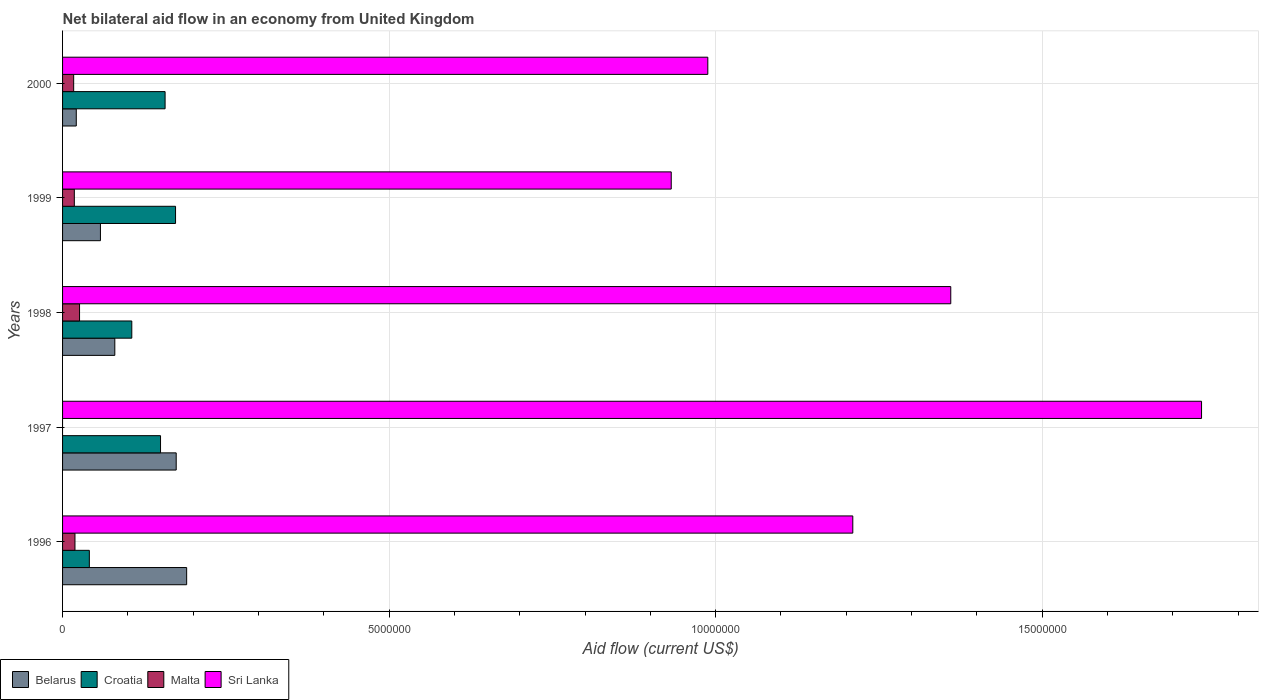Are the number of bars per tick equal to the number of legend labels?
Ensure brevity in your answer.  No. Are the number of bars on each tick of the Y-axis equal?
Provide a short and direct response. No. How many bars are there on the 4th tick from the top?
Make the answer very short. 3. Across all years, what is the maximum net bilateral aid flow in Belarus?
Your response must be concise. 1.90e+06. Across all years, what is the minimum net bilateral aid flow in Malta?
Make the answer very short. 0. What is the total net bilateral aid flow in Belarus in the graph?
Your response must be concise. 5.23e+06. What is the difference between the net bilateral aid flow in Belarus in 1997 and that in 2000?
Make the answer very short. 1.53e+06. What is the difference between the net bilateral aid flow in Sri Lanka in 1996 and the net bilateral aid flow in Malta in 1999?
Your answer should be very brief. 1.19e+07. In the year 2000, what is the difference between the net bilateral aid flow in Belarus and net bilateral aid flow in Croatia?
Offer a very short reply. -1.36e+06. In how many years, is the net bilateral aid flow in Croatia greater than 5000000 US$?
Offer a terse response. 0. What is the ratio of the net bilateral aid flow in Malta in 1996 to that in 2000?
Make the answer very short. 1.12. What is the difference between the highest and the second highest net bilateral aid flow in Sri Lanka?
Your answer should be very brief. 3.84e+06. What is the difference between the highest and the lowest net bilateral aid flow in Croatia?
Your answer should be very brief. 1.32e+06. In how many years, is the net bilateral aid flow in Belarus greater than the average net bilateral aid flow in Belarus taken over all years?
Keep it short and to the point. 2. Is the sum of the net bilateral aid flow in Malta in 1996 and 1999 greater than the maximum net bilateral aid flow in Sri Lanka across all years?
Your answer should be compact. No. How many years are there in the graph?
Make the answer very short. 5. Does the graph contain any zero values?
Ensure brevity in your answer.  Yes. How many legend labels are there?
Provide a succinct answer. 4. What is the title of the graph?
Offer a very short reply. Net bilateral aid flow in an economy from United Kingdom. Does "Montenegro" appear as one of the legend labels in the graph?
Provide a succinct answer. No. What is the Aid flow (current US$) in Belarus in 1996?
Your answer should be very brief. 1.90e+06. What is the Aid flow (current US$) of Croatia in 1996?
Your answer should be compact. 4.10e+05. What is the Aid flow (current US$) of Sri Lanka in 1996?
Your response must be concise. 1.21e+07. What is the Aid flow (current US$) in Belarus in 1997?
Your response must be concise. 1.74e+06. What is the Aid flow (current US$) of Croatia in 1997?
Provide a short and direct response. 1.50e+06. What is the Aid flow (current US$) in Sri Lanka in 1997?
Your answer should be compact. 1.74e+07. What is the Aid flow (current US$) in Belarus in 1998?
Make the answer very short. 8.00e+05. What is the Aid flow (current US$) of Croatia in 1998?
Offer a terse response. 1.06e+06. What is the Aid flow (current US$) in Sri Lanka in 1998?
Your response must be concise. 1.36e+07. What is the Aid flow (current US$) of Belarus in 1999?
Provide a short and direct response. 5.80e+05. What is the Aid flow (current US$) of Croatia in 1999?
Your answer should be very brief. 1.73e+06. What is the Aid flow (current US$) of Malta in 1999?
Your answer should be very brief. 1.80e+05. What is the Aid flow (current US$) in Sri Lanka in 1999?
Provide a succinct answer. 9.32e+06. What is the Aid flow (current US$) in Belarus in 2000?
Your response must be concise. 2.10e+05. What is the Aid flow (current US$) in Croatia in 2000?
Your response must be concise. 1.57e+06. What is the Aid flow (current US$) in Malta in 2000?
Provide a short and direct response. 1.70e+05. What is the Aid flow (current US$) in Sri Lanka in 2000?
Provide a short and direct response. 9.88e+06. Across all years, what is the maximum Aid flow (current US$) of Belarus?
Provide a succinct answer. 1.90e+06. Across all years, what is the maximum Aid flow (current US$) of Croatia?
Your answer should be very brief. 1.73e+06. Across all years, what is the maximum Aid flow (current US$) of Sri Lanka?
Give a very brief answer. 1.74e+07. Across all years, what is the minimum Aid flow (current US$) in Croatia?
Your answer should be very brief. 4.10e+05. Across all years, what is the minimum Aid flow (current US$) of Malta?
Keep it short and to the point. 0. Across all years, what is the minimum Aid flow (current US$) in Sri Lanka?
Make the answer very short. 9.32e+06. What is the total Aid flow (current US$) in Belarus in the graph?
Make the answer very short. 5.23e+06. What is the total Aid flow (current US$) of Croatia in the graph?
Give a very brief answer. 6.27e+06. What is the total Aid flow (current US$) of Sri Lanka in the graph?
Make the answer very short. 6.23e+07. What is the difference between the Aid flow (current US$) of Belarus in 1996 and that in 1997?
Provide a short and direct response. 1.60e+05. What is the difference between the Aid flow (current US$) in Croatia in 1996 and that in 1997?
Provide a succinct answer. -1.09e+06. What is the difference between the Aid flow (current US$) in Sri Lanka in 1996 and that in 1997?
Ensure brevity in your answer.  -5.34e+06. What is the difference between the Aid flow (current US$) of Belarus in 1996 and that in 1998?
Give a very brief answer. 1.10e+06. What is the difference between the Aid flow (current US$) in Croatia in 1996 and that in 1998?
Your response must be concise. -6.50e+05. What is the difference between the Aid flow (current US$) in Malta in 1996 and that in 1998?
Give a very brief answer. -7.00e+04. What is the difference between the Aid flow (current US$) in Sri Lanka in 1996 and that in 1998?
Your answer should be compact. -1.50e+06. What is the difference between the Aid flow (current US$) in Belarus in 1996 and that in 1999?
Make the answer very short. 1.32e+06. What is the difference between the Aid flow (current US$) in Croatia in 1996 and that in 1999?
Keep it short and to the point. -1.32e+06. What is the difference between the Aid flow (current US$) of Malta in 1996 and that in 1999?
Give a very brief answer. 10000. What is the difference between the Aid flow (current US$) of Sri Lanka in 1996 and that in 1999?
Provide a succinct answer. 2.78e+06. What is the difference between the Aid flow (current US$) in Belarus in 1996 and that in 2000?
Your answer should be very brief. 1.69e+06. What is the difference between the Aid flow (current US$) in Croatia in 1996 and that in 2000?
Offer a very short reply. -1.16e+06. What is the difference between the Aid flow (current US$) in Sri Lanka in 1996 and that in 2000?
Keep it short and to the point. 2.22e+06. What is the difference between the Aid flow (current US$) of Belarus in 1997 and that in 1998?
Provide a short and direct response. 9.40e+05. What is the difference between the Aid flow (current US$) in Sri Lanka in 1997 and that in 1998?
Offer a terse response. 3.84e+06. What is the difference between the Aid flow (current US$) in Belarus in 1997 and that in 1999?
Offer a very short reply. 1.16e+06. What is the difference between the Aid flow (current US$) of Croatia in 1997 and that in 1999?
Ensure brevity in your answer.  -2.30e+05. What is the difference between the Aid flow (current US$) in Sri Lanka in 1997 and that in 1999?
Provide a succinct answer. 8.12e+06. What is the difference between the Aid flow (current US$) of Belarus in 1997 and that in 2000?
Your response must be concise. 1.53e+06. What is the difference between the Aid flow (current US$) in Sri Lanka in 1997 and that in 2000?
Keep it short and to the point. 7.56e+06. What is the difference between the Aid flow (current US$) of Belarus in 1998 and that in 1999?
Keep it short and to the point. 2.20e+05. What is the difference between the Aid flow (current US$) in Croatia in 1998 and that in 1999?
Provide a short and direct response. -6.70e+05. What is the difference between the Aid flow (current US$) in Malta in 1998 and that in 1999?
Provide a short and direct response. 8.00e+04. What is the difference between the Aid flow (current US$) of Sri Lanka in 1998 and that in 1999?
Your response must be concise. 4.28e+06. What is the difference between the Aid flow (current US$) in Belarus in 1998 and that in 2000?
Keep it short and to the point. 5.90e+05. What is the difference between the Aid flow (current US$) of Croatia in 1998 and that in 2000?
Provide a succinct answer. -5.10e+05. What is the difference between the Aid flow (current US$) in Sri Lanka in 1998 and that in 2000?
Offer a terse response. 3.72e+06. What is the difference between the Aid flow (current US$) in Belarus in 1999 and that in 2000?
Provide a short and direct response. 3.70e+05. What is the difference between the Aid flow (current US$) of Croatia in 1999 and that in 2000?
Your answer should be compact. 1.60e+05. What is the difference between the Aid flow (current US$) in Malta in 1999 and that in 2000?
Ensure brevity in your answer.  10000. What is the difference between the Aid flow (current US$) of Sri Lanka in 1999 and that in 2000?
Your answer should be compact. -5.60e+05. What is the difference between the Aid flow (current US$) in Belarus in 1996 and the Aid flow (current US$) in Sri Lanka in 1997?
Provide a short and direct response. -1.55e+07. What is the difference between the Aid flow (current US$) in Croatia in 1996 and the Aid flow (current US$) in Sri Lanka in 1997?
Your answer should be very brief. -1.70e+07. What is the difference between the Aid flow (current US$) in Malta in 1996 and the Aid flow (current US$) in Sri Lanka in 1997?
Provide a short and direct response. -1.72e+07. What is the difference between the Aid flow (current US$) in Belarus in 1996 and the Aid flow (current US$) in Croatia in 1998?
Keep it short and to the point. 8.40e+05. What is the difference between the Aid flow (current US$) of Belarus in 1996 and the Aid flow (current US$) of Malta in 1998?
Offer a very short reply. 1.64e+06. What is the difference between the Aid flow (current US$) of Belarus in 1996 and the Aid flow (current US$) of Sri Lanka in 1998?
Your answer should be very brief. -1.17e+07. What is the difference between the Aid flow (current US$) in Croatia in 1996 and the Aid flow (current US$) in Malta in 1998?
Make the answer very short. 1.50e+05. What is the difference between the Aid flow (current US$) in Croatia in 1996 and the Aid flow (current US$) in Sri Lanka in 1998?
Ensure brevity in your answer.  -1.32e+07. What is the difference between the Aid flow (current US$) in Malta in 1996 and the Aid flow (current US$) in Sri Lanka in 1998?
Your answer should be very brief. -1.34e+07. What is the difference between the Aid flow (current US$) of Belarus in 1996 and the Aid flow (current US$) of Malta in 1999?
Your answer should be very brief. 1.72e+06. What is the difference between the Aid flow (current US$) in Belarus in 1996 and the Aid flow (current US$) in Sri Lanka in 1999?
Your answer should be very brief. -7.42e+06. What is the difference between the Aid flow (current US$) in Croatia in 1996 and the Aid flow (current US$) in Sri Lanka in 1999?
Make the answer very short. -8.91e+06. What is the difference between the Aid flow (current US$) of Malta in 1996 and the Aid flow (current US$) of Sri Lanka in 1999?
Give a very brief answer. -9.13e+06. What is the difference between the Aid flow (current US$) in Belarus in 1996 and the Aid flow (current US$) in Croatia in 2000?
Keep it short and to the point. 3.30e+05. What is the difference between the Aid flow (current US$) in Belarus in 1996 and the Aid flow (current US$) in Malta in 2000?
Your answer should be very brief. 1.73e+06. What is the difference between the Aid flow (current US$) in Belarus in 1996 and the Aid flow (current US$) in Sri Lanka in 2000?
Offer a terse response. -7.98e+06. What is the difference between the Aid flow (current US$) in Croatia in 1996 and the Aid flow (current US$) in Malta in 2000?
Provide a succinct answer. 2.40e+05. What is the difference between the Aid flow (current US$) of Croatia in 1996 and the Aid flow (current US$) of Sri Lanka in 2000?
Give a very brief answer. -9.47e+06. What is the difference between the Aid flow (current US$) in Malta in 1996 and the Aid flow (current US$) in Sri Lanka in 2000?
Your answer should be very brief. -9.69e+06. What is the difference between the Aid flow (current US$) of Belarus in 1997 and the Aid flow (current US$) of Croatia in 1998?
Your response must be concise. 6.80e+05. What is the difference between the Aid flow (current US$) of Belarus in 1997 and the Aid flow (current US$) of Malta in 1998?
Your answer should be compact. 1.48e+06. What is the difference between the Aid flow (current US$) of Belarus in 1997 and the Aid flow (current US$) of Sri Lanka in 1998?
Provide a short and direct response. -1.19e+07. What is the difference between the Aid flow (current US$) in Croatia in 1997 and the Aid flow (current US$) in Malta in 1998?
Provide a short and direct response. 1.24e+06. What is the difference between the Aid flow (current US$) of Croatia in 1997 and the Aid flow (current US$) of Sri Lanka in 1998?
Offer a very short reply. -1.21e+07. What is the difference between the Aid flow (current US$) of Belarus in 1997 and the Aid flow (current US$) of Croatia in 1999?
Your answer should be compact. 10000. What is the difference between the Aid flow (current US$) of Belarus in 1997 and the Aid flow (current US$) of Malta in 1999?
Offer a terse response. 1.56e+06. What is the difference between the Aid flow (current US$) of Belarus in 1997 and the Aid flow (current US$) of Sri Lanka in 1999?
Keep it short and to the point. -7.58e+06. What is the difference between the Aid flow (current US$) in Croatia in 1997 and the Aid flow (current US$) in Malta in 1999?
Your answer should be very brief. 1.32e+06. What is the difference between the Aid flow (current US$) in Croatia in 1997 and the Aid flow (current US$) in Sri Lanka in 1999?
Provide a succinct answer. -7.82e+06. What is the difference between the Aid flow (current US$) in Belarus in 1997 and the Aid flow (current US$) in Malta in 2000?
Give a very brief answer. 1.57e+06. What is the difference between the Aid flow (current US$) of Belarus in 1997 and the Aid flow (current US$) of Sri Lanka in 2000?
Offer a very short reply. -8.14e+06. What is the difference between the Aid flow (current US$) of Croatia in 1997 and the Aid flow (current US$) of Malta in 2000?
Make the answer very short. 1.33e+06. What is the difference between the Aid flow (current US$) in Croatia in 1997 and the Aid flow (current US$) in Sri Lanka in 2000?
Your answer should be very brief. -8.38e+06. What is the difference between the Aid flow (current US$) of Belarus in 1998 and the Aid flow (current US$) of Croatia in 1999?
Make the answer very short. -9.30e+05. What is the difference between the Aid flow (current US$) of Belarus in 1998 and the Aid flow (current US$) of Malta in 1999?
Your response must be concise. 6.20e+05. What is the difference between the Aid flow (current US$) in Belarus in 1998 and the Aid flow (current US$) in Sri Lanka in 1999?
Offer a terse response. -8.52e+06. What is the difference between the Aid flow (current US$) in Croatia in 1998 and the Aid flow (current US$) in Malta in 1999?
Keep it short and to the point. 8.80e+05. What is the difference between the Aid flow (current US$) of Croatia in 1998 and the Aid flow (current US$) of Sri Lanka in 1999?
Your answer should be very brief. -8.26e+06. What is the difference between the Aid flow (current US$) in Malta in 1998 and the Aid flow (current US$) in Sri Lanka in 1999?
Provide a succinct answer. -9.06e+06. What is the difference between the Aid flow (current US$) in Belarus in 1998 and the Aid flow (current US$) in Croatia in 2000?
Keep it short and to the point. -7.70e+05. What is the difference between the Aid flow (current US$) in Belarus in 1998 and the Aid flow (current US$) in Malta in 2000?
Provide a short and direct response. 6.30e+05. What is the difference between the Aid flow (current US$) in Belarus in 1998 and the Aid flow (current US$) in Sri Lanka in 2000?
Offer a very short reply. -9.08e+06. What is the difference between the Aid flow (current US$) in Croatia in 1998 and the Aid flow (current US$) in Malta in 2000?
Your answer should be very brief. 8.90e+05. What is the difference between the Aid flow (current US$) in Croatia in 1998 and the Aid flow (current US$) in Sri Lanka in 2000?
Your answer should be compact. -8.82e+06. What is the difference between the Aid flow (current US$) of Malta in 1998 and the Aid flow (current US$) of Sri Lanka in 2000?
Give a very brief answer. -9.62e+06. What is the difference between the Aid flow (current US$) of Belarus in 1999 and the Aid flow (current US$) of Croatia in 2000?
Offer a very short reply. -9.90e+05. What is the difference between the Aid flow (current US$) of Belarus in 1999 and the Aid flow (current US$) of Malta in 2000?
Offer a very short reply. 4.10e+05. What is the difference between the Aid flow (current US$) in Belarus in 1999 and the Aid flow (current US$) in Sri Lanka in 2000?
Provide a succinct answer. -9.30e+06. What is the difference between the Aid flow (current US$) in Croatia in 1999 and the Aid flow (current US$) in Malta in 2000?
Your answer should be very brief. 1.56e+06. What is the difference between the Aid flow (current US$) of Croatia in 1999 and the Aid flow (current US$) of Sri Lanka in 2000?
Provide a succinct answer. -8.15e+06. What is the difference between the Aid flow (current US$) of Malta in 1999 and the Aid flow (current US$) of Sri Lanka in 2000?
Make the answer very short. -9.70e+06. What is the average Aid flow (current US$) of Belarus per year?
Ensure brevity in your answer.  1.05e+06. What is the average Aid flow (current US$) in Croatia per year?
Offer a very short reply. 1.25e+06. What is the average Aid flow (current US$) of Sri Lanka per year?
Provide a succinct answer. 1.25e+07. In the year 1996, what is the difference between the Aid flow (current US$) of Belarus and Aid flow (current US$) of Croatia?
Offer a terse response. 1.49e+06. In the year 1996, what is the difference between the Aid flow (current US$) in Belarus and Aid flow (current US$) in Malta?
Ensure brevity in your answer.  1.71e+06. In the year 1996, what is the difference between the Aid flow (current US$) in Belarus and Aid flow (current US$) in Sri Lanka?
Keep it short and to the point. -1.02e+07. In the year 1996, what is the difference between the Aid flow (current US$) in Croatia and Aid flow (current US$) in Sri Lanka?
Your answer should be very brief. -1.17e+07. In the year 1996, what is the difference between the Aid flow (current US$) of Malta and Aid flow (current US$) of Sri Lanka?
Your answer should be very brief. -1.19e+07. In the year 1997, what is the difference between the Aid flow (current US$) of Belarus and Aid flow (current US$) of Sri Lanka?
Provide a short and direct response. -1.57e+07. In the year 1997, what is the difference between the Aid flow (current US$) of Croatia and Aid flow (current US$) of Sri Lanka?
Ensure brevity in your answer.  -1.59e+07. In the year 1998, what is the difference between the Aid flow (current US$) in Belarus and Aid flow (current US$) in Malta?
Keep it short and to the point. 5.40e+05. In the year 1998, what is the difference between the Aid flow (current US$) of Belarus and Aid flow (current US$) of Sri Lanka?
Provide a short and direct response. -1.28e+07. In the year 1998, what is the difference between the Aid flow (current US$) of Croatia and Aid flow (current US$) of Sri Lanka?
Your answer should be very brief. -1.25e+07. In the year 1998, what is the difference between the Aid flow (current US$) in Malta and Aid flow (current US$) in Sri Lanka?
Provide a succinct answer. -1.33e+07. In the year 1999, what is the difference between the Aid flow (current US$) in Belarus and Aid flow (current US$) in Croatia?
Make the answer very short. -1.15e+06. In the year 1999, what is the difference between the Aid flow (current US$) of Belarus and Aid flow (current US$) of Malta?
Your answer should be compact. 4.00e+05. In the year 1999, what is the difference between the Aid flow (current US$) of Belarus and Aid flow (current US$) of Sri Lanka?
Your answer should be very brief. -8.74e+06. In the year 1999, what is the difference between the Aid flow (current US$) in Croatia and Aid flow (current US$) in Malta?
Your answer should be very brief. 1.55e+06. In the year 1999, what is the difference between the Aid flow (current US$) of Croatia and Aid flow (current US$) of Sri Lanka?
Provide a short and direct response. -7.59e+06. In the year 1999, what is the difference between the Aid flow (current US$) in Malta and Aid flow (current US$) in Sri Lanka?
Provide a succinct answer. -9.14e+06. In the year 2000, what is the difference between the Aid flow (current US$) of Belarus and Aid flow (current US$) of Croatia?
Provide a succinct answer. -1.36e+06. In the year 2000, what is the difference between the Aid flow (current US$) in Belarus and Aid flow (current US$) in Sri Lanka?
Make the answer very short. -9.67e+06. In the year 2000, what is the difference between the Aid flow (current US$) in Croatia and Aid flow (current US$) in Malta?
Keep it short and to the point. 1.40e+06. In the year 2000, what is the difference between the Aid flow (current US$) of Croatia and Aid flow (current US$) of Sri Lanka?
Your answer should be compact. -8.31e+06. In the year 2000, what is the difference between the Aid flow (current US$) of Malta and Aid flow (current US$) of Sri Lanka?
Offer a very short reply. -9.71e+06. What is the ratio of the Aid flow (current US$) of Belarus in 1996 to that in 1997?
Ensure brevity in your answer.  1.09. What is the ratio of the Aid flow (current US$) of Croatia in 1996 to that in 1997?
Your answer should be compact. 0.27. What is the ratio of the Aid flow (current US$) of Sri Lanka in 1996 to that in 1997?
Your response must be concise. 0.69. What is the ratio of the Aid flow (current US$) of Belarus in 1996 to that in 1998?
Your answer should be very brief. 2.38. What is the ratio of the Aid flow (current US$) in Croatia in 1996 to that in 1998?
Provide a short and direct response. 0.39. What is the ratio of the Aid flow (current US$) of Malta in 1996 to that in 1998?
Offer a terse response. 0.73. What is the ratio of the Aid flow (current US$) in Sri Lanka in 1996 to that in 1998?
Your answer should be compact. 0.89. What is the ratio of the Aid flow (current US$) in Belarus in 1996 to that in 1999?
Make the answer very short. 3.28. What is the ratio of the Aid flow (current US$) of Croatia in 1996 to that in 1999?
Your response must be concise. 0.24. What is the ratio of the Aid flow (current US$) of Malta in 1996 to that in 1999?
Ensure brevity in your answer.  1.06. What is the ratio of the Aid flow (current US$) in Sri Lanka in 1996 to that in 1999?
Make the answer very short. 1.3. What is the ratio of the Aid flow (current US$) in Belarus in 1996 to that in 2000?
Make the answer very short. 9.05. What is the ratio of the Aid flow (current US$) of Croatia in 1996 to that in 2000?
Your answer should be compact. 0.26. What is the ratio of the Aid flow (current US$) in Malta in 1996 to that in 2000?
Your answer should be very brief. 1.12. What is the ratio of the Aid flow (current US$) of Sri Lanka in 1996 to that in 2000?
Provide a succinct answer. 1.22. What is the ratio of the Aid flow (current US$) of Belarus in 1997 to that in 1998?
Make the answer very short. 2.17. What is the ratio of the Aid flow (current US$) of Croatia in 1997 to that in 1998?
Ensure brevity in your answer.  1.42. What is the ratio of the Aid flow (current US$) of Sri Lanka in 1997 to that in 1998?
Make the answer very short. 1.28. What is the ratio of the Aid flow (current US$) of Croatia in 1997 to that in 1999?
Provide a succinct answer. 0.87. What is the ratio of the Aid flow (current US$) in Sri Lanka in 1997 to that in 1999?
Give a very brief answer. 1.87. What is the ratio of the Aid flow (current US$) of Belarus in 1997 to that in 2000?
Provide a short and direct response. 8.29. What is the ratio of the Aid flow (current US$) in Croatia in 1997 to that in 2000?
Offer a very short reply. 0.96. What is the ratio of the Aid flow (current US$) of Sri Lanka in 1997 to that in 2000?
Offer a very short reply. 1.77. What is the ratio of the Aid flow (current US$) in Belarus in 1998 to that in 1999?
Make the answer very short. 1.38. What is the ratio of the Aid flow (current US$) in Croatia in 1998 to that in 1999?
Provide a succinct answer. 0.61. What is the ratio of the Aid flow (current US$) in Malta in 1998 to that in 1999?
Ensure brevity in your answer.  1.44. What is the ratio of the Aid flow (current US$) of Sri Lanka in 1998 to that in 1999?
Offer a terse response. 1.46. What is the ratio of the Aid flow (current US$) in Belarus in 1998 to that in 2000?
Keep it short and to the point. 3.81. What is the ratio of the Aid flow (current US$) of Croatia in 1998 to that in 2000?
Ensure brevity in your answer.  0.68. What is the ratio of the Aid flow (current US$) of Malta in 1998 to that in 2000?
Ensure brevity in your answer.  1.53. What is the ratio of the Aid flow (current US$) in Sri Lanka in 1998 to that in 2000?
Offer a terse response. 1.38. What is the ratio of the Aid flow (current US$) of Belarus in 1999 to that in 2000?
Provide a succinct answer. 2.76. What is the ratio of the Aid flow (current US$) of Croatia in 1999 to that in 2000?
Your answer should be compact. 1.1. What is the ratio of the Aid flow (current US$) in Malta in 1999 to that in 2000?
Ensure brevity in your answer.  1.06. What is the ratio of the Aid flow (current US$) of Sri Lanka in 1999 to that in 2000?
Offer a terse response. 0.94. What is the difference between the highest and the second highest Aid flow (current US$) in Croatia?
Provide a succinct answer. 1.60e+05. What is the difference between the highest and the second highest Aid flow (current US$) of Sri Lanka?
Offer a very short reply. 3.84e+06. What is the difference between the highest and the lowest Aid flow (current US$) in Belarus?
Your answer should be compact. 1.69e+06. What is the difference between the highest and the lowest Aid flow (current US$) of Croatia?
Keep it short and to the point. 1.32e+06. What is the difference between the highest and the lowest Aid flow (current US$) of Malta?
Offer a terse response. 2.60e+05. What is the difference between the highest and the lowest Aid flow (current US$) in Sri Lanka?
Your response must be concise. 8.12e+06. 